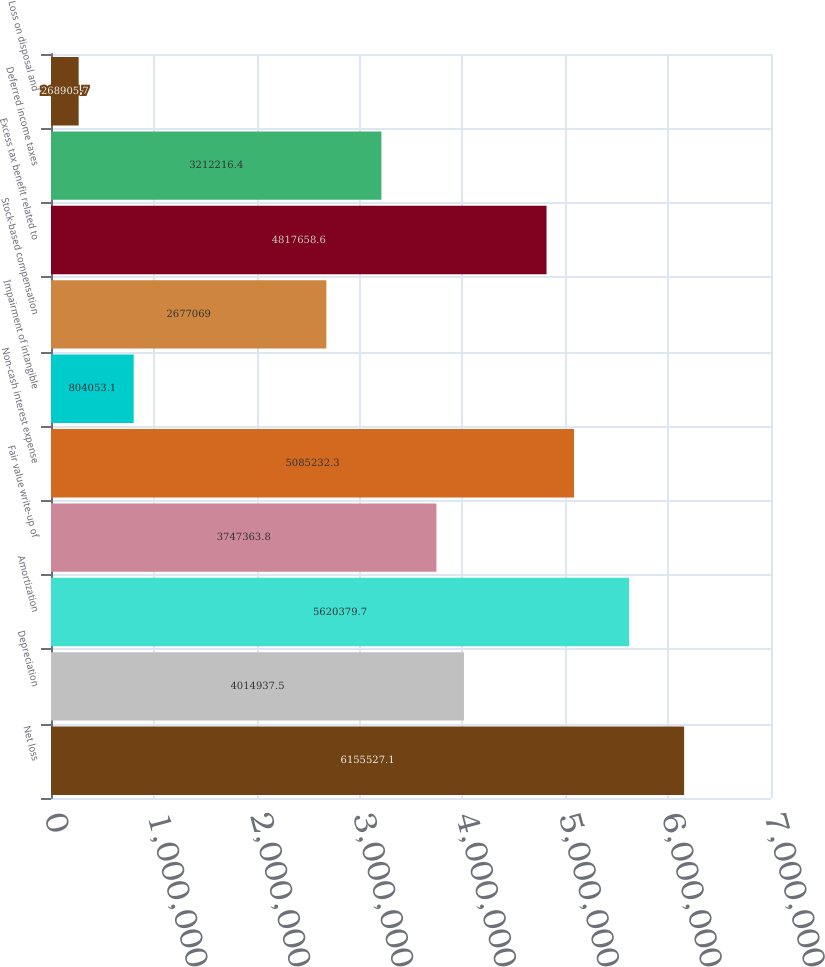Convert chart. <chart><loc_0><loc_0><loc_500><loc_500><bar_chart><fcel>Net loss<fcel>Depreciation<fcel>Amortization<fcel>Fair value write-up of<fcel>Non-cash interest expense<fcel>Impairment of intangible<fcel>Stock-based compensation<fcel>Excess tax benefit related to<fcel>Deferred income taxes<fcel>Loss on disposal and<nl><fcel>6.15553e+06<fcel>4.01494e+06<fcel>5.62038e+06<fcel>3.74736e+06<fcel>5.08523e+06<fcel>804053<fcel>2.67707e+06<fcel>4.81766e+06<fcel>3.21222e+06<fcel>268906<nl></chart> 